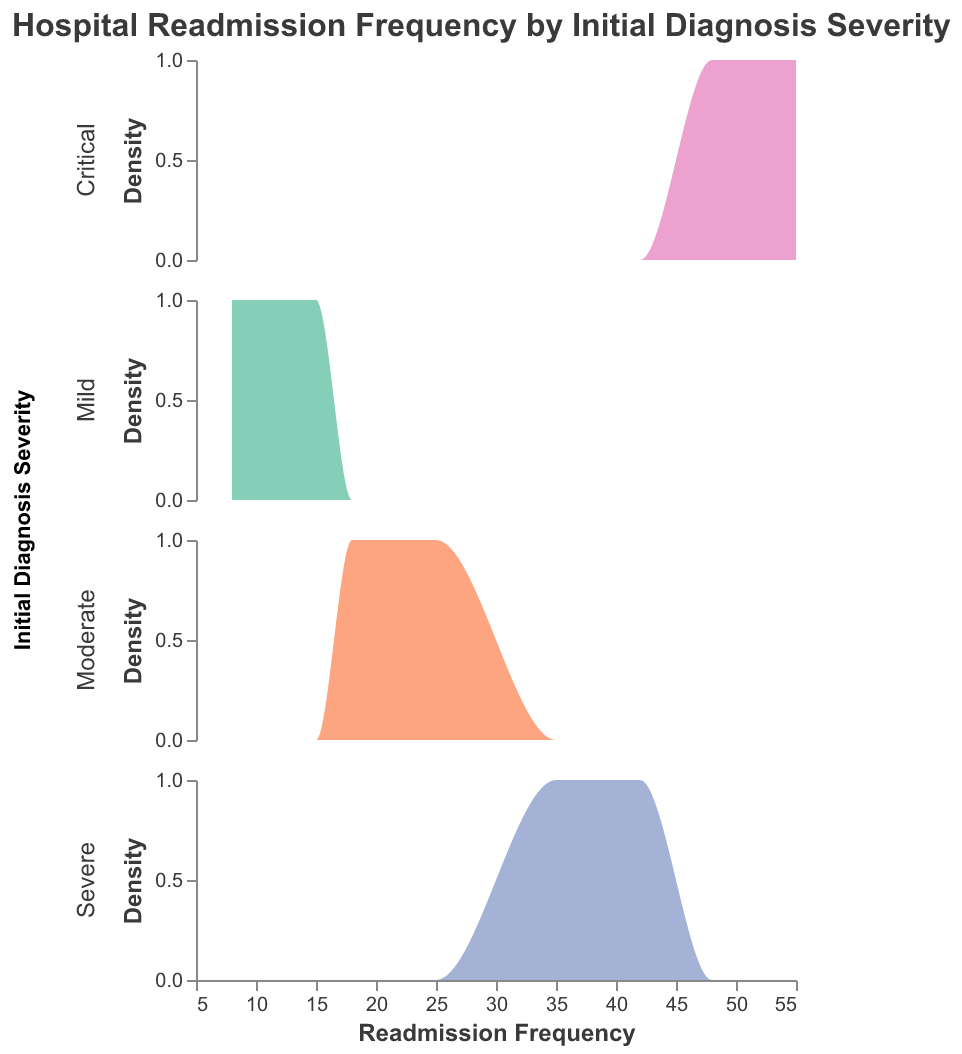What is the title of the plot? The title of the plot is displayed at the top of the figure. It reads "Hospital Readmission Frequency by Initial Diagnosis Severity".
Answer: Hospital Readmission Frequency by Initial Diagnosis Severity What are the colors used for different initial diagnosis severities? The plot uses different colors to distinguish the severities: Mild is green, Moderate is orange, Severe is blue, and Critical is pink.
Answer: green, orange, blue, pink What is the range of readmission frequencies for the "Severe" category? Looking at the x-axis under the "Severe" category, the readmission frequencies range from 35 to 42.
Answer: 35 to 42 Which severity category has the highest readmission frequency? By inspecting the highest readmission frequencies for each severity level, the "Critical" category has the highest value at 55.
Answer: Critical Which severity category shows the largest variability in readmission frequencies? By comparing the spread of the frequencies on the x-axis for each subplot, "Critical" has the widest range from 48 to 55, indicating the largest variability.
Answer: Critical How many readmission frequency data points are shown for the "Moderate" severity? Count the number of peaks under the "Moderate" category subplot. There are four readmission frequency data points: 18, 22, 19, and 25.
Answer: 4 Which category has the least density of readmission frequencies around the median? To find this, compare the concentration of density curves near the median frequency for each category. "Mild" shows lower density around its median compared to other categories, indicating fewer readmissions around its center.
Answer: Mild What is the most common readmission frequency for the "Mild" category? The highest peak in the "Mild" subplot indicates the most common readmission frequency. It peaks at 15.
Answer: 15 Based on the density plots, which severity categories seem to overlap the most? Checking for areas where curves might overlap in density value distribution, "Severe" and "Critical" categories show some overlap around the lower frequency values (35-40 for Severe versus 48 for Critical).
Answer: Severe and Critical How does the density distribution shape differ between "Mild" and "Critical" severities? The "Mild" category has a more narrow, peaked distribution compared to the flatter, wider spread seen in the "Critical" category. This indicates that "Mild" has less variability in readmission frequencies, whereas "Critical" has more.
Answer: "Mild" is narrow and peaked; "Critical" is flat and wide 